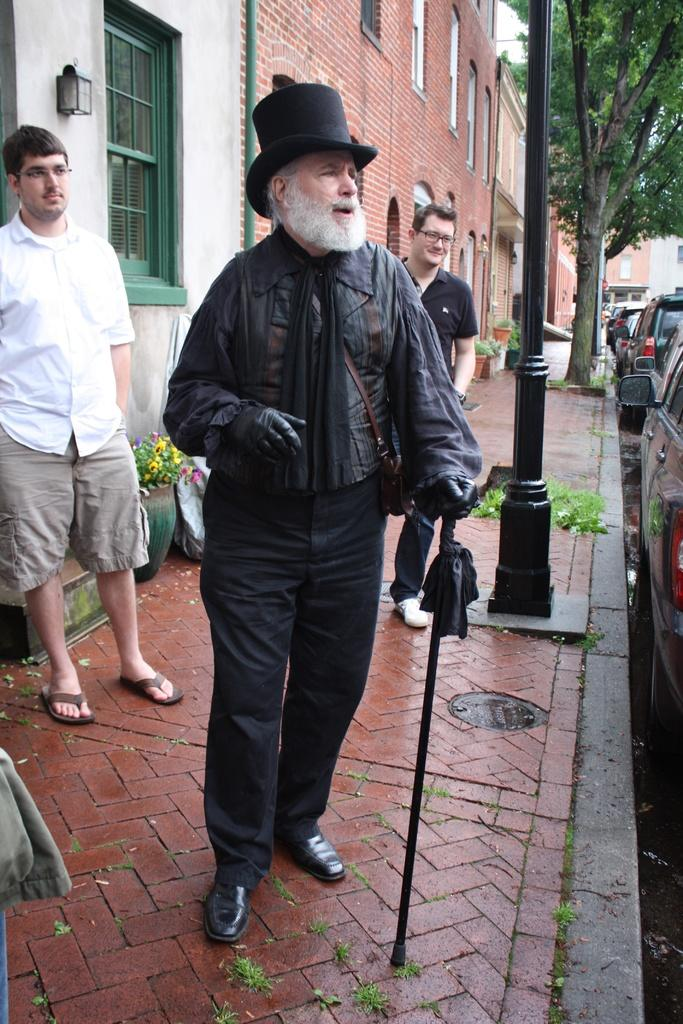What can be seen on the footpath in the image? There are people on the footpath in the image. What else is visible near the footpath? Vehicles are visible beside the footpath. Are there any plants in the image? Yes, house plants are present in the image. What type of structures can be seen in the image? There are buildings in the image. Can you describe any unspecified objects in the image? Unfortunately, the provided facts do not specify the nature of these unspecified objects. How many spots can be seen on the ship in the image? There is no ship present in the image. What type of legs are visible on the people in the image? The provided facts do not specify the type of legs visible on the people in the image. 